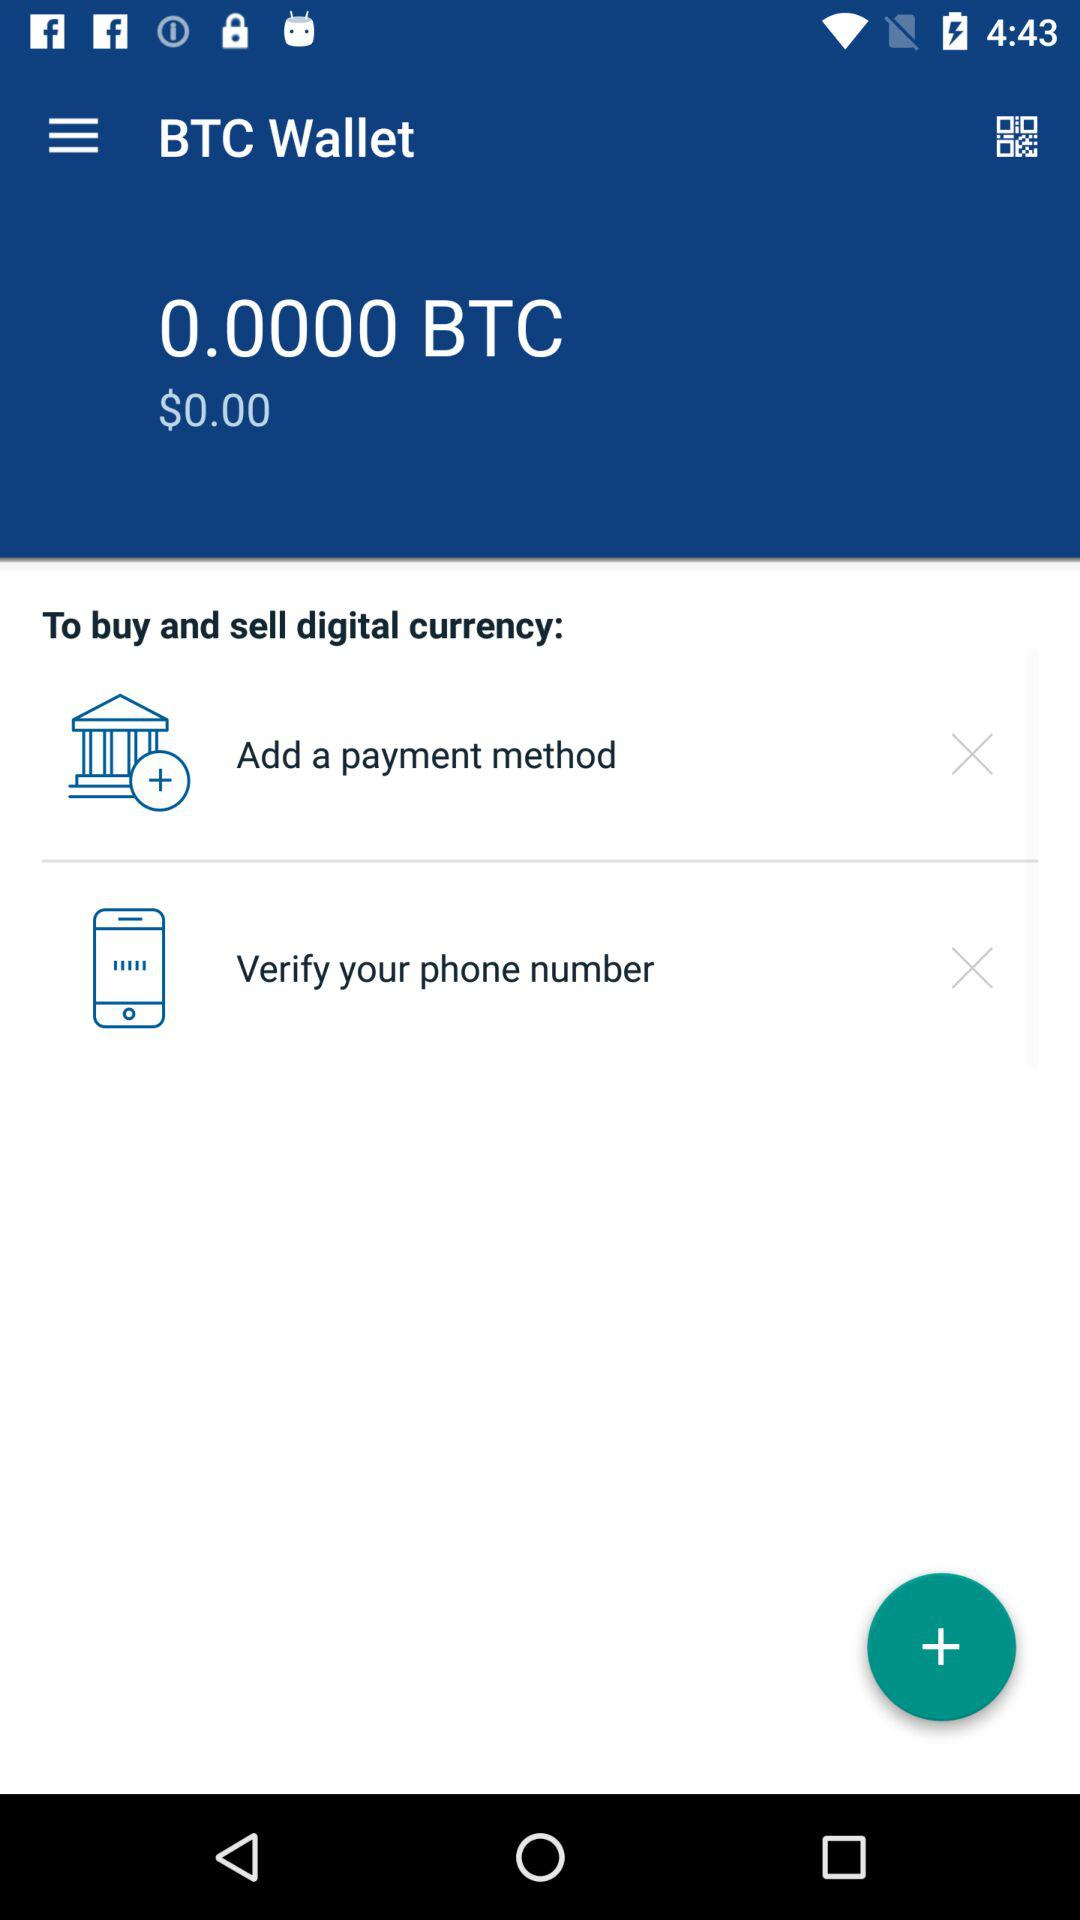How many sections are there in the terms of service?
Answer the question using a single word or phrase. 4 